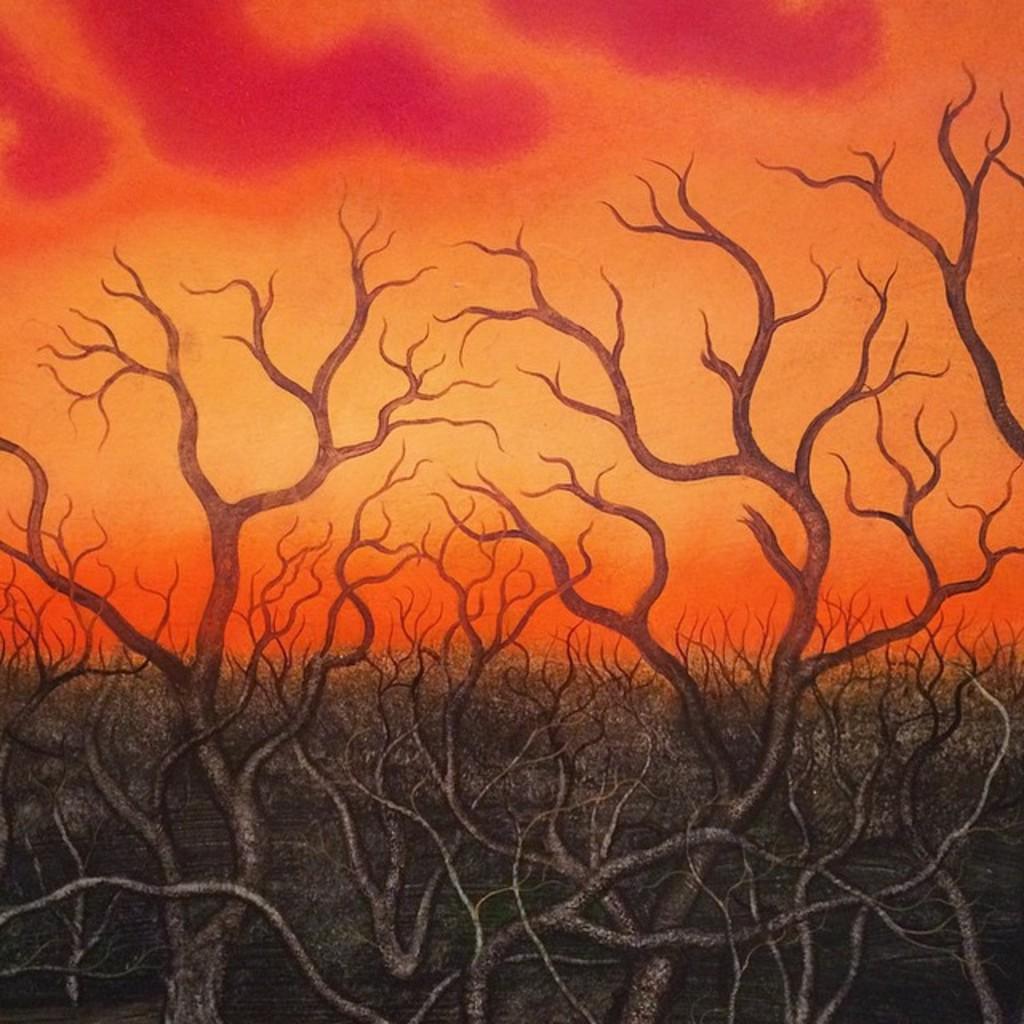Can you describe this image briefly? In this image we can see paintings of roots and branches. In the background of the painting it is in orange and pink shade.   